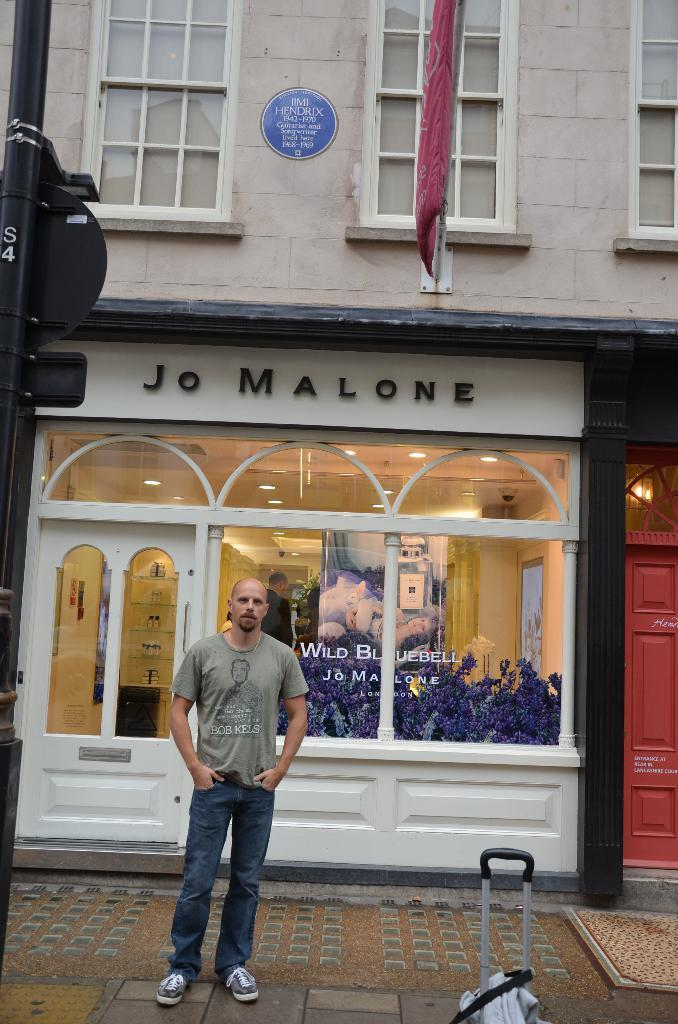What is the main subject of the image? There is a man in the image. What is the man doing in the image? The man is standing. What type of clothing is the man wearing? The man is wearing a t-shirt and trousers. What can be seen in the background of the image? There is a glass wall in the image, which is part of a building. What type of drain is visible in the image? There is no drain present in the image. Is the man cooking on a stove in the image? There is no stove present in the image. 